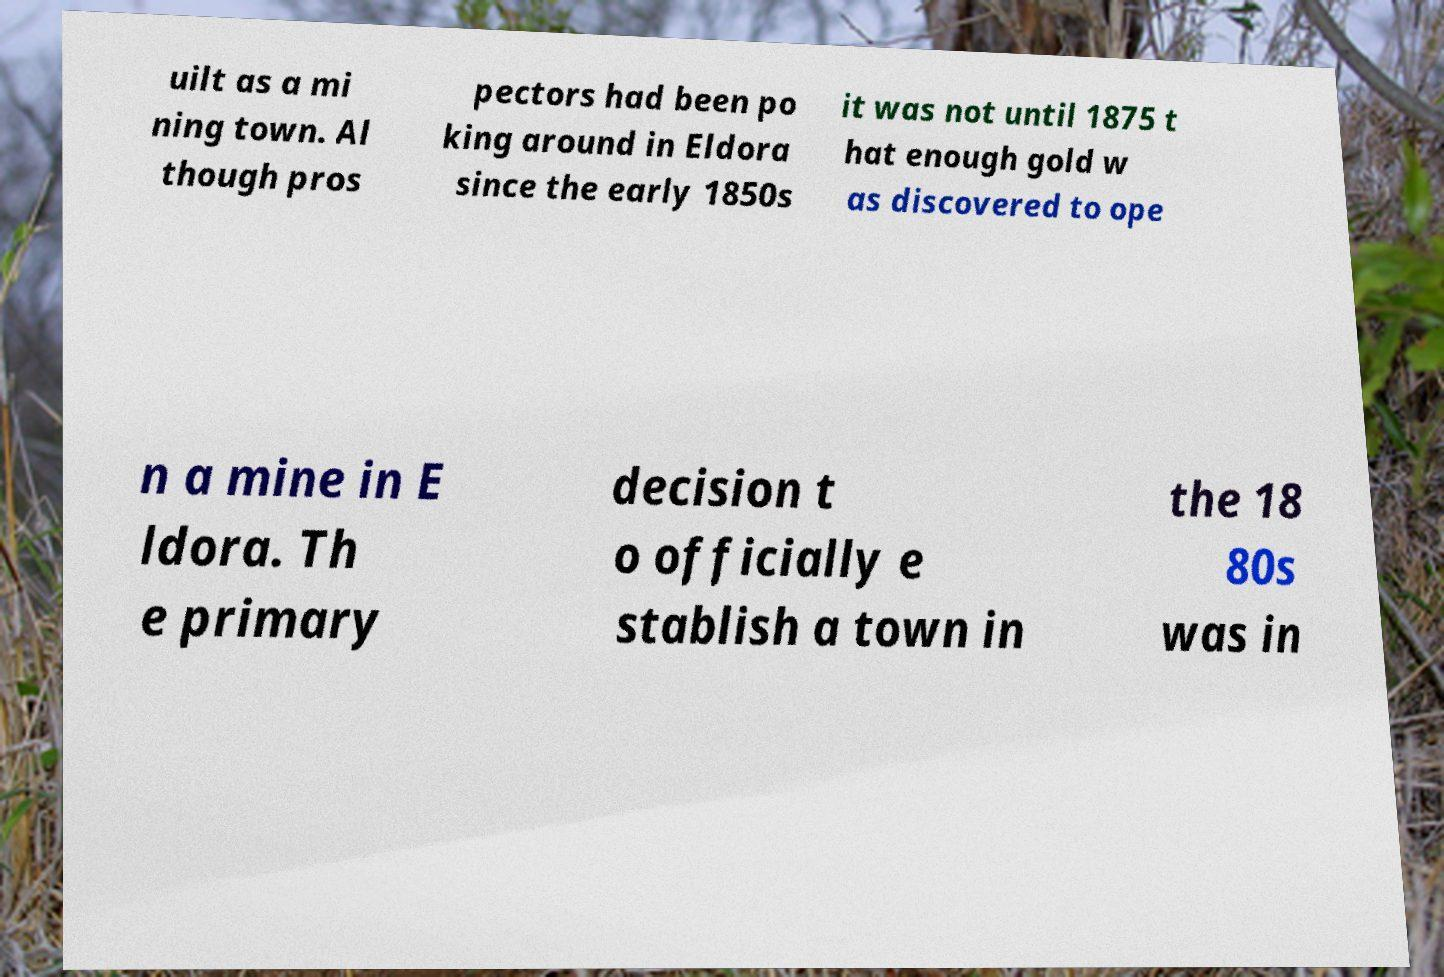For documentation purposes, I need the text within this image transcribed. Could you provide that? uilt as a mi ning town. Al though pros pectors had been po king around in Eldora since the early 1850s it was not until 1875 t hat enough gold w as discovered to ope n a mine in E ldora. Th e primary decision t o officially e stablish a town in the 18 80s was in 